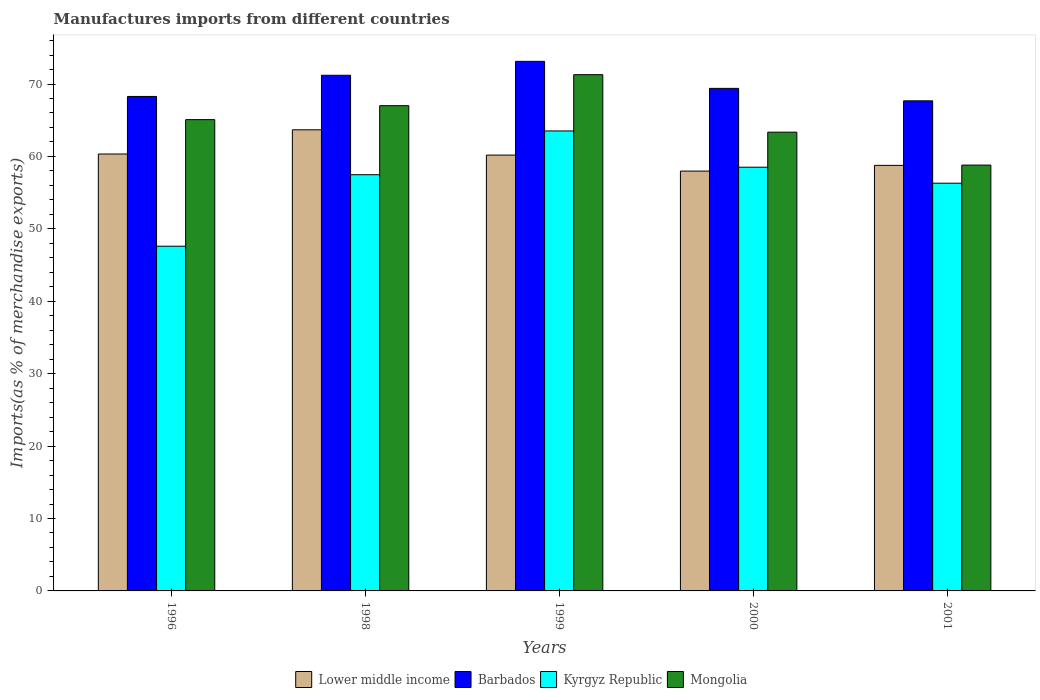How many different coloured bars are there?
Your answer should be very brief. 4. How many groups of bars are there?
Provide a succinct answer. 5. Are the number of bars on each tick of the X-axis equal?
Your answer should be compact. Yes. How many bars are there on the 2nd tick from the right?
Provide a succinct answer. 4. In how many cases, is the number of bars for a given year not equal to the number of legend labels?
Provide a short and direct response. 0. What is the percentage of imports to different countries in Barbados in 1996?
Your response must be concise. 68.28. Across all years, what is the maximum percentage of imports to different countries in Lower middle income?
Offer a terse response. 63.67. Across all years, what is the minimum percentage of imports to different countries in Lower middle income?
Provide a short and direct response. 57.98. What is the total percentage of imports to different countries in Mongolia in the graph?
Make the answer very short. 325.53. What is the difference between the percentage of imports to different countries in Lower middle income in 1998 and that in 2001?
Keep it short and to the point. 4.91. What is the difference between the percentage of imports to different countries in Lower middle income in 2001 and the percentage of imports to different countries in Mongolia in 1999?
Make the answer very short. -12.52. What is the average percentage of imports to different countries in Kyrgyz Republic per year?
Offer a terse response. 56.68. In the year 1999, what is the difference between the percentage of imports to different countries in Mongolia and percentage of imports to different countries in Kyrgyz Republic?
Your answer should be compact. 7.77. What is the ratio of the percentage of imports to different countries in Mongolia in 1998 to that in 2000?
Your answer should be very brief. 1.06. What is the difference between the highest and the second highest percentage of imports to different countries in Barbados?
Offer a terse response. 1.92. What is the difference between the highest and the lowest percentage of imports to different countries in Barbados?
Your answer should be very brief. 5.45. Is it the case that in every year, the sum of the percentage of imports to different countries in Mongolia and percentage of imports to different countries in Barbados is greater than the sum of percentage of imports to different countries in Lower middle income and percentage of imports to different countries in Kyrgyz Republic?
Give a very brief answer. Yes. What does the 3rd bar from the left in 1999 represents?
Give a very brief answer. Kyrgyz Republic. What does the 4th bar from the right in 1999 represents?
Give a very brief answer. Lower middle income. Is it the case that in every year, the sum of the percentage of imports to different countries in Barbados and percentage of imports to different countries in Lower middle income is greater than the percentage of imports to different countries in Kyrgyz Republic?
Make the answer very short. Yes. Are all the bars in the graph horizontal?
Offer a very short reply. No. What is the difference between two consecutive major ticks on the Y-axis?
Provide a succinct answer. 10. Are the values on the major ticks of Y-axis written in scientific E-notation?
Your response must be concise. No. Does the graph contain any zero values?
Your response must be concise. No. Does the graph contain grids?
Provide a succinct answer. No. Where does the legend appear in the graph?
Your answer should be compact. Bottom center. How are the legend labels stacked?
Keep it short and to the point. Horizontal. What is the title of the graph?
Your answer should be very brief. Manufactures imports from different countries. What is the label or title of the Y-axis?
Your answer should be very brief. Imports(as % of merchandise exports). What is the Imports(as % of merchandise exports) of Lower middle income in 1996?
Offer a terse response. 60.33. What is the Imports(as % of merchandise exports) of Barbados in 1996?
Offer a very short reply. 68.28. What is the Imports(as % of merchandise exports) in Kyrgyz Republic in 1996?
Provide a short and direct response. 47.6. What is the Imports(as % of merchandise exports) in Mongolia in 1996?
Provide a short and direct response. 65.08. What is the Imports(as % of merchandise exports) in Lower middle income in 1998?
Your answer should be compact. 63.67. What is the Imports(as % of merchandise exports) of Barbados in 1998?
Ensure brevity in your answer.  71.2. What is the Imports(as % of merchandise exports) of Kyrgyz Republic in 1998?
Make the answer very short. 57.47. What is the Imports(as % of merchandise exports) of Mongolia in 1998?
Ensure brevity in your answer.  67.01. What is the Imports(as % of merchandise exports) in Lower middle income in 1999?
Make the answer very short. 60.18. What is the Imports(as % of merchandise exports) of Barbados in 1999?
Your answer should be compact. 73.13. What is the Imports(as % of merchandise exports) in Kyrgyz Republic in 1999?
Offer a terse response. 63.52. What is the Imports(as % of merchandise exports) of Mongolia in 1999?
Make the answer very short. 71.29. What is the Imports(as % of merchandise exports) in Lower middle income in 2000?
Provide a short and direct response. 57.98. What is the Imports(as % of merchandise exports) in Barbados in 2000?
Your response must be concise. 69.4. What is the Imports(as % of merchandise exports) of Kyrgyz Republic in 2000?
Your answer should be very brief. 58.51. What is the Imports(as % of merchandise exports) of Mongolia in 2000?
Give a very brief answer. 63.35. What is the Imports(as % of merchandise exports) of Lower middle income in 2001?
Provide a short and direct response. 58.76. What is the Imports(as % of merchandise exports) of Barbados in 2001?
Provide a succinct answer. 67.67. What is the Imports(as % of merchandise exports) in Kyrgyz Republic in 2001?
Offer a terse response. 56.3. What is the Imports(as % of merchandise exports) in Mongolia in 2001?
Keep it short and to the point. 58.8. Across all years, what is the maximum Imports(as % of merchandise exports) of Lower middle income?
Provide a short and direct response. 63.67. Across all years, what is the maximum Imports(as % of merchandise exports) of Barbados?
Provide a succinct answer. 73.13. Across all years, what is the maximum Imports(as % of merchandise exports) of Kyrgyz Republic?
Provide a succinct answer. 63.52. Across all years, what is the maximum Imports(as % of merchandise exports) in Mongolia?
Offer a terse response. 71.29. Across all years, what is the minimum Imports(as % of merchandise exports) of Lower middle income?
Provide a succinct answer. 57.98. Across all years, what is the minimum Imports(as % of merchandise exports) of Barbados?
Your response must be concise. 67.67. Across all years, what is the minimum Imports(as % of merchandise exports) of Kyrgyz Republic?
Make the answer very short. 47.6. Across all years, what is the minimum Imports(as % of merchandise exports) in Mongolia?
Your answer should be compact. 58.8. What is the total Imports(as % of merchandise exports) of Lower middle income in the graph?
Provide a succinct answer. 300.93. What is the total Imports(as % of merchandise exports) of Barbados in the graph?
Offer a very short reply. 349.68. What is the total Imports(as % of merchandise exports) in Kyrgyz Republic in the graph?
Offer a terse response. 283.4. What is the total Imports(as % of merchandise exports) in Mongolia in the graph?
Provide a short and direct response. 325.53. What is the difference between the Imports(as % of merchandise exports) of Lower middle income in 1996 and that in 1998?
Your answer should be very brief. -3.34. What is the difference between the Imports(as % of merchandise exports) of Barbados in 1996 and that in 1998?
Ensure brevity in your answer.  -2.92. What is the difference between the Imports(as % of merchandise exports) in Kyrgyz Republic in 1996 and that in 1998?
Provide a succinct answer. -9.87. What is the difference between the Imports(as % of merchandise exports) in Mongolia in 1996 and that in 1998?
Your answer should be very brief. -1.93. What is the difference between the Imports(as % of merchandise exports) of Lower middle income in 1996 and that in 1999?
Offer a terse response. 0.15. What is the difference between the Imports(as % of merchandise exports) of Barbados in 1996 and that in 1999?
Provide a succinct answer. -4.85. What is the difference between the Imports(as % of merchandise exports) of Kyrgyz Republic in 1996 and that in 1999?
Your response must be concise. -15.92. What is the difference between the Imports(as % of merchandise exports) of Mongolia in 1996 and that in 1999?
Keep it short and to the point. -6.21. What is the difference between the Imports(as % of merchandise exports) of Lower middle income in 1996 and that in 2000?
Make the answer very short. 2.36. What is the difference between the Imports(as % of merchandise exports) of Barbados in 1996 and that in 2000?
Your response must be concise. -1.12. What is the difference between the Imports(as % of merchandise exports) of Kyrgyz Republic in 1996 and that in 2000?
Give a very brief answer. -10.91. What is the difference between the Imports(as % of merchandise exports) in Mongolia in 1996 and that in 2000?
Provide a succinct answer. 1.73. What is the difference between the Imports(as % of merchandise exports) in Lower middle income in 1996 and that in 2001?
Provide a succinct answer. 1.57. What is the difference between the Imports(as % of merchandise exports) in Barbados in 1996 and that in 2001?
Your answer should be compact. 0.61. What is the difference between the Imports(as % of merchandise exports) of Kyrgyz Republic in 1996 and that in 2001?
Keep it short and to the point. -8.7. What is the difference between the Imports(as % of merchandise exports) in Mongolia in 1996 and that in 2001?
Provide a succinct answer. 6.28. What is the difference between the Imports(as % of merchandise exports) of Lower middle income in 1998 and that in 1999?
Provide a short and direct response. 3.49. What is the difference between the Imports(as % of merchandise exports) of Barbados in 1998 and that in 1999?
Your response must be concise. -1.92. What is the difference between the Imports(as % of merchandise exports) of Kyrgyz Republic in 1998 and that in 1999?
Give a very brief answer. -6.04. What is the difference between the Imports(as % of merchandise exports) in Mongolia in 1998 and that in 1999?
Provide a short and direct response. -4.28. What is the difference between the Imports(as % of merchandise exports) of Lower middle income in 1998 and that in 2000?
Offer a terse response. 5.7. What is the difference between the Imports(as % of merchandise exports) in Barbados in 1998 and that in 2000?
Your answer should be compact. 1.81. What is the difference between the Imports(as % of merchandise exports) of Kyrgyz Republic in 1998 and that in 2000?
Your answer should be compact. -1.04. What is the difference between the Imports(as % of merchandise exports) in Mongolia in 1998 and that in 2000?
Provide a short and direct response. 3.66. What is the difference between the Imports(as % of merchandise exports) of Lower middle income in 1998 and that in 2001?
Offer a terse response. 4.91. What is the difference between the Imports(as % of merchandise exports) in Barbados in 1998 and that in 2001?
Provide a short and direct response. 3.53. What is the difference between the Imports(as % of merchandise exports) in Kyrgyz Republic in 1998 and that in 2001?
Make the answer very short. 1.17. What is the difference between the Imports(as % of merchandise exports) in Mongolia in 1998 and that in 2001?
Ensure brevity in your answer.  8.2. What is the difference between the Imports(as % of merchandise exports) in Lower middle income in 1999 and that in 2000?
Your response must be concise. 2.21. What is the difference between the Imports(as % of merchandise exports) of Barbados in 1999 and that in 2000?
Ensure brevity in your answer.  3.73. What is the difference between the Imports(as % of merchandise exports) in Kyrgyz Republic in 1999 and that in 2000?
Offer a very short reply. 5.01. What is the difference between the Imports(as % of merchandise exports) in Mongolia in 1999 and that in 2000?
Your response must be concise. 7.94. What is the difference between the Imports(as % of merchandise exports) of Lower middle income in 1999 and that in 2001?
Provide a succinct answer. 1.42. What is the difference between the Imports(as % of merchandise exports) of Barbados in 1999 and that in 2001?
Provide a succinct answer. 5.45. What is the difference between the Imports(as % of merchandise exports) in Kyrgyz Republic in 1999 and that in 2001?
Make the answer very short. 7.21. What is the difference between the Imports(as % of merchandise exports) of Mongolia in 1999 and that in 2001?
Your answer should be very brief. 12.48. What is the difference between the Imports(as % of merchandise exports) of Lower middle income in 2000 and that in 2001?
Provide a short and direct response. -0.79. What is the difference between the Imports(as % of merchandise exports) in Barbados in 2000 and that in 2001?
Give a very brief answer. 1.72. What is the difference between the Imports(as % of merchandise exports) of Kyrgyz Republic in 2000 and that in 2001?
Your response must be concise. 2.21. What is the difference between the Imports(as % of merchandise exports) in Mongolia in 2000 and that in 2001?
Provide a short and direct response. 4.55. What is the difference between the Imports(as % of merchandise exports) of Lower middle income in 1996 and the Imports(as % of merchandise exports) of Barbados in 1998?
Ensure brevity in your answer.  -10.87. What is the difference between the Imports(as % of merchandise exports) in Lower middle income in 1996 and the Imports(as % of merchandise exports) in Kyrgyz Republic in 1998?
Ensure brevity in your answer.  2.86. What is the difference between the Imports(as % of merchandise exports) in Lower middle income in 1996 and the Imports(as % of merchandise exports) in Mongolia in 1998?
Give a very brief answer. -6.67. What is the difference between the Imports(as % of merchandise exports) of Barbados in 1996 and the Imports(as % of merchandise exports) of Kyrgyz Republic in 1998?
Provide a short and direct response. 10.81. What is the difference between the Imports(as % of merchandise exports) in Barbados in 1996 and the Imports(as % of merchandise exports) in Mongolia in 1998?
Offer a terse response. 1.28. What is the difference between the Imports(as % of merchandise exports) of Kyrgyz Republic in 1996 and the Imports(as % of merchandise exports) of Mongolia in 1998?
Make the answer very short. -19.4. What is the difference between the Imports(as % of merchandise exports) in Lower middle income in 1996 and the Imports(as % of merchandise exports) in Barbados in 1999?
Your response must be concise. -12.79. What is the difference between the Imports(as % of merchandise exports) of Lower middle income in 1996 and the Imports(as % of merchandise exports) of Kyrgyz Republic in 1999?
Keep it short and to the point. -3.18. What is the difference between the Imports(as % of merchandise exports) in Lower middle income in 1996 and the Imports(as % of merchandise exports) in Mongolia in 1999?
Provide a short and direct response. -10.96. What is the difference between the Imports(as % of merchandise exports) of Barbados in 1996 and the Imports(as % of merchandise exports) of Kyrgyz Republic in 1999?
Offer a very short reply. 4.77. What is the difference between the Imports(as % of merchandise exports) in Barbados in 1996 and the Imports(as % of merchandise exports) in Mongolia in 1999?
Your response must be concise. -3.01. What is the difference between the Imports(as % of merchandise exports) of Kyrgyz Republic in 1996 and the Imports(as % of merchandise exports) of Mongolia in 1999?
Provide a succinct answer. -23.69. What is the difference between the Imports(as % of merchandise exports) in Lower middle income in 1996 and the Imports(as % of merchandise exports) in Barbados in 2000?
Give a very brief answer. -9.06. What is the difference between the Imports(as % of merchandise exports) in Lower middle income in 1996 and the Imports(as % of merchandise exports) in Kyrgyz Republic in 2000?
Your answer should be compact. 1.82. What is the difference between the Imports(as % of merchandise exports) of Lower middle income in 1996 and the Imports(as % of merchandise exports) of Mongolia in 2000?
Ensure brevity in your answer.  -3.02. What is the difference between the Imports(as % of merchandise exports) in Barbados in 1996 and the Imports(as % of merchandise exports) in Kyrgyz Republic in 2000?
Offer a terse response. 9.77. What is the difference between the Imports(as % of merchandise exports) of Barbados in 1996 and the Imports(as % of merchandise exports) of Mongolia in 2000?
Keep it short and to the point. 4.93. What is the difference between the Imports(as % of merchandise exports) in Kyrgyz Republic in 1996 and the Imports(as % of merchandise exports) in Mongolia in 2000?
Your answer should be compact. -15.75. What is the difference between the Imports(as % of merchandise exports) in Lower middle income in 1996 and the Imports(as % of merchandise exports) in Barbados in 2001?
Ensure brevity in your answer.  -7.34. What is the difference between the Imports(as % of merchandise exports) of Lower middle income in 1996 and the Imports(as % of merchandise exports) of Kyrgyz Republic in 2001?
Offer a very short reply. 4.03. What is the difference between the Imports(as % of merchandise exports) of Lower middle income in 1996 and the Imports(as % of merchandise exports) of Mongolia in 2001?
Your response must be concise. 1.53. What is the difference between the Imports(as % of merchandise exports) in Barbados in 1996 and the Imports(as % of merchandise exports) in Kyrgyz Republic in 2001?
Your answer should be compact. 11.98. What is the difference between the Imports(as % of merchandise exports) of Barbados in 1996 and the Imports(as % of merchandise exports) of Mongolia in 2001?
Your response must be concise. 9.48. What is the difference between the Imports(as % of merchandise exports) in Kyrgyz Republic in 1996 and the Imports(as % of merchandise exports) in Mongolia in 2001?
Provide a short and direct response. -11.2. What is the difference between the Imports(as % of merchandise exports) of Lower middle income in 1998 and the Imports(as % of merchandise exports) of Barbados in 1999?
Keep it short and to the point. -9.45. What is the difference between the Imports(as % of merchandise exports) of Lower middle income in 1998 and the Imports(as % of merchandise exports) of Kyrgyz Republic in 1999?
Offer a very short reply. 0.16. What is the difference between the Imports(as % of merchandise exports) in Lower middle income in 1998 and the Imports(as % of merchandise exports) in Mongolia in 1999?
Make the answer very short. -7.61. What is the difference between the Imports(as % of merchandise exports) of Barbados in 1998 and the Imports(as % of merchandise exports) of Kyrgyz Republic in 1999?
Your answer should be compact. 7.69. What is the difference between the Imports(as % of merchandise exports) of Barbados in 1998 and the Imports(as % of merchandise exports) of Mongolia in 1999?
Provide a succinct answer. -0.08. What is the difference between the Imports(as % of merchandise exports) in Kyrgyz Republic in 1998 and the Imports(as % of merchandise exports) in Mongolia in 1999?
Offer a terse response. -13.81. What is the difference between the Imports(as % of merchandise exports) in Lower middle income in 1998 and the Imports(as % of merchandise exports) in Barbados in 2000?
Offer a terse response. -5.72. What is the difference between the Imports(as % of merchandise exports) in Lower middle income in 1998 and the Imports(as % of merchandise exports) in Kyrgyz Republic in 2000?
Your answer should be very brief. 5.16. What is the difference between the Imports(as % of merchandise exports) in Lower middle income in 1998 and the Imports(as % of merchandise exports) in Mongolia in 2000?
Ensure brevity in your answer.  0.32. What is the difference between the Imports(as % of merchandise exports) in Barbados in 1998 and the Imports(as % of merchandise exports) in Kyrgyz Republic in 2000?
Your response must be concise. 12.69. What is the difference between the Imports(as % of merchandise exports) in Barbados in 1998 and the Imports(as % of merchandise exports) in Mongolia in 2000?
Your answer should be very brief. 7.85. What is the difference between the Imports(as % of merchandise exports) of Kyrgyz Republic in 1998 and the Imports(as % of merchandise exports) of Mongolia in 2000?
Provide a succinct answer. -5.88. What is the difference between the Imports(as % of merchandise exports) in Lower middle income in 1998 and the Imports(as % of merchandise exports) in Barbados in 2001?
Make the answer very short. -4. What is the difference between the Imports(as % of merchandise exports) in Lower middle income in 1998 and the Imports(as % of merchandise exports) in Kyrgyz Republic in 2001?
Offer a terse response. 7.37. What is the difference between the Imports(as % of merchandise exports) of Lower middle income in 1998 and the Imports(as % of merchandise exports) of Mongolia in 2001?
Offer a terse response. 4.87. What is the difference between the Imports(as % of merchandise exports) in Barbados in 1998 and the Imports(as % of merchandise exports) in Kyrgyz Republic in 2001?
Ensure brevity in your answer.  14.9. What is the difference between the Imports(as % of merchandise exports) of Barbados in 1998 and the Imports(as % of merchandise exports) of Mongolia in 2001?
Give a very brief answer. 12.4. What is the difference between the Imports(as % of merchandise exports) of Kyrgyz Republic in 1998 and the Imports(as % of merchandise exports) of Mongolia in 2001?
Give a very brief answer. -1.33. What is the difference between the Imports(as % of merchandise exports) in Lower middle income in 1999 and the Imports(as % of merchandise exports) in Barbados in 2000?
Keep it short and to the point. -9.21. What is the difference between the Imports(as % of merchandise exports) in Lower middle income in 1999 and the Imports(as % of merchandise exports) in Kyrgyz Republic in 2000?
Provide a short and direct response. 1.67. What is the difference between the Imports(as % of merchandise exports) of Lower middle income in 1999 and the Imports(as % of merchandise exports) of Mongolia in 2000?
Your answer should be compact. -3.17. What is the difference between the Imports(as % of merchandise exports) of Barbados in 1999 and the Imports(as % of merchandise exports) of Kyrgyz Republic in 2000?
Offer a terse response. 14.62. What is the difference between the Imports(as % of merchandise exports) in Barbados in 1999 and the Imports(as % of merchandise exports) in Mongolia in 2000?
Provide a succinct answer. 9.78. What is the difference between the Imports(as % of merchandise exports) in Kyrgyz Republic in 1999 and the Imports(as % of merchandise exports) in Mongolia in 2000?
Make the answer very short. 0.17. What is the difference between the Imports(as % of merchandise exports) of Lower middle income in 1999 and the Imports(as % of merchandise exports) of Barbados in 2001?
Ensure brevity in your answer.  -7.49. What is the difference between the Imports(as % of merchandise exports) in Lower middle income in 1999 and the Imports(as % of merchandise exports) in Kyrgyz Republic in 2001?
Ensure brevity in your answer.  3.88. What is the difference between the Imports(as % of merchandise exports) of Lower middle income in 1999 and the Imports(as % of merchandise exports) of Mongolia in 2001?
Your answer should be compact. 1.38. What is the difference between the Imports(as % of merchandise exports) of Barbados in 1999 and the Imports(as % of merchandise exports) of Kyrgyz Republic in 2001?
Offer a terse response. 16.82. What is the difference between the Imports(as % of merchandise exports) in Barbados in 1999 and the Imports(as % of merchandise exports) in Mongolia in 2001?
Offer a terse response. 14.32. What is the difference between the Imports(as % of merchandise exports) in Kyrgyz Republic in 1999 and the Imports(as % of merchandise exports) in Mongolia in 2001?
Your answer should be compact. 4.71. What is the difference between the Imports(as % of merchandise exports) of Lower middle income in 2000 and the Imports(as % of merchandise exports) of Barbados in 2001?
Offer a very short reply. -9.7. What is the difference between the Imports(as % of merchandise exports) of Lower middle income in 2000 and the Imports(as % of merchandise exports) of Kyrgyz Republic in 2001?
Offer a terse response. 1.67. What is the difference between the Imports(as % of merchandise exports) in Lower middle income in 2000 and the Imports(as % of merchandise exports) in Mongolia in 2001?
Your response must be concise. -0.83. What is the difference between the Imports(as % of merchandise exports) of Barbados in 2000 and the Imports(as % of merchandise exports) of Kyrgyz Republic in 2001?
Provide a succinct answer. 13.09. What is the difference between the Imports(as % of merchandise exports) of Barbados in 2000 and the Imports(as % of merchandise exports) of Mongolia in 2001?
Your answer should be compact. 10.59. What is the difference between the Imports(as % of merchandise exports) of Kyrgyz Republic in 2000 and the Imports(as % of merchandise exports) of Mongolia in 2001?
Give a very brief answer. -0.29. What is the average Imports(as % of merchandise exports) in Lower middle income per year?
Your response must be concise. 60.19. What is the average Imports(as % of merchandise exports) of Barbados per year?
Provide a short and direct response. 69.94. What is the average Imports(as % of merchandise exports) of Kyrgyz Republic per year?
Ensure brevity in your answer.  56.68. What is the average Imports(as % of merchandise exports) of Mongolia per year?
Offer a very short reply. 65.11. In the year 1996, what is the difference between the Imports(as % of merchandise exports) in Lower middle income and Imports(as % of merchandise exports) in Barbados?
Offer a terse response. -7.95. In the year 1996, what is the difference between the Imports(as % of merchandise exports) of Lower middle income and Imports(as % of merchandise exports) of Kyrgyz Republic?
Your answer should be compact. 12.73. In the year 1996, what is the difference between the Imports(as % of merchandise exports) of Lower middle income and Imports(as % of merchandise exports) of Mongolia?
Give a very brief answer. -4.75. In the year 1996, what is the difference between the Imports(as % of merchandise exports) in Barbados and Imports(as % of merchandise exports) in Kyrgyz Republic?
Provide a succinct answer. 20.68. In the year 1996, what is the difference between the Imports(as % of merchandise exports) of Barbados and Imports(as % of merchandise exports) of Mongolia?
Offer a very short reply. 3.2. In the year 1996, what is the difference between the Imports(as % of merchandise exports) in Kyrgyz Republic and Imports(as % of merchandise exports) in Mongolia?
Your answer should be very brief. -17.48. In the year 1998, what is the difference between the Imports(as % of merchandise exports) of Lower middle income and Imports(as % of merchandise exports) of Barbados?
Provide a short and direct response. -7.53. In the year 1998, what is the difference between the Imports(as % of merchandise exports) of Lower middle income and Imports(as % of merchandise exports) of Kyrgyz Republic?
Offer a very short reply. 6.2. In the year 1998, what is the difference between the Imports(as % of merchandise exports) in Lower middle income and Imports(as % of merchandise exports) in Mongolia?
Offer a very short reply. -3.33. In the year 1998, what is the difference between the Imports(as % of merchandise exports) of Barbados and Imports(as % of merchandise exports) of Kyrgyz Republic?
Make the answer very short. 13.73. In the year 1998, what is the difference between the Imports(as % of merchandise exports) in Barbados and Imports(as % of merchandise exports) in Mongolia?
Your answer should be very brief. 4.2. In the year 1998, what is the difference between the Imports(as % of merchandise exports) of Kyrgyz Republic and Imports(as % of merchandise exports) of Mongolia?
Provide a short and direct response. -9.53. In the year 1999, what is the difference between the Imports(as % of merchandise exports) of Lower middle income and Imports(as % of merchandise exports) of Barbados?
Your response must be concise. -12.95. In the year 1999, what is the difference between the Imports(as % of merchandise exports) in Lower middle income and Imports(as % of merchandise exports) in Kyrgyz Republic?
Provide a succinct answer. -3.33. In the year 1999, what is the difference between the Imports(as % of merchandise exports) in Lower middle income and Imports(as % of merchandise exports) in Mongolia?
Your answer should be very brief. -11.11. In the year 1999, what is the difference between the Imports(as % of merchandise exports) of Barbados and Imports(as % of merchandise exports) of Kyrgyz Republic?
Offer a very short reply. 9.61. In the year 1999, what is the difference between the Imports(as % of merchandise exports) of Barbados and Imports(as % of merchandise exports) of Mongolia?
Ensure brevity in your answer.  1.84. In the year 1999, what is the difference between the Imports(as % of merchandise exports) of Kyrgyz Republic and Imports(as % of merchandise exports) of Mongolia?
Provide a short and direct response. -7.77. In the year 2000, what is the difference between the Imports(as % of merchandise exports) in Lower middle income and Imports(as % of merchandise exports) in Barbados?
Ensure brevity in your answer.  -11.42. In the year 2000, what is the difference between the Imports(as % of merchandise exports) in Lower middle income and Imports(as % of merchandise exports) in Kyrgyz Republic?
Keep it short and to the point. -0.53. In the year 2000, what is the difference between the Imports(as % of merchandise exports) of Lower middle income and Imports(as % of merchandise exports) of Mongolia?
Your response must be concise. -5.37. In the year 2000, what is the difference between the Imports(as % of merchandise exports) in Barbados and Imports(as % of merchandise exports) in Kyrgyz Republic?
Keep it short and to the point. 10.89. In the year 2000, what is the difference between the Imports(as % of merchandise exports) of Barbados and Imports(as % of merchandise exports) of Mongolia?
Provide a succinct answer. 6.05. In the year 2000, what is the difference between the Imports(as % of merchandise exports) in Kyrgyz Republic and Imports(as % of merchandise exports) in Mongolia?
Make the answer very short. -4.84. In the year 2001, what is the difference between the Imports(as % of merchandise exports) of Lower middle income and Imports(as % of merchandise exports) of Barbados?
Provide a short and direct response. -8.91. In the year 2001, what is the difference between the Imports(as % of merchandise exports) of Lower middle income and Imports(as % of merchandise exports) of Kyrgyz Republic?
Your answer should be compact. 2.46. In the year 2001, what is the difference between the Imports(as % of merchandise exports) of Lower middle income and Imports(as % of merchandise exports) of Mongolia?
Your answer should be very brief. -0.04. In the year 2001, what is the difference between the Imports(as % of merchandise exports) of Barbados and Imports(as % of merchandise exports) of Kyrgyz Republic?
Your response must be concise. 11.37. In the year 2001, what is the difference between the Imports(as % of merchandise exports) of Barbados and Imports(as % of merchandise exports) of Mongolia?
Your answer should be very brief. 8.87. In the year 2001, what is the difference between the Imports(as % of merchandise exports) in Kyrgyz Republic and Imports(as % of merchandise exports) in Mongolia?
Offer a very short reply. -2.5. What is the ratio of the Imports(as % of merchandise exports) of Lower middle income in 1996 to that in 1998?
Keep it short and to the point. 0.95. What is the ratio of the Imports(as % of merchandise exports) in Kyrgyz Republic in 1996 to that in 1998?
Your answer should be very brief. 0.83. What is the ratio of the Imports(as % of merchandise exports) in Mongolia in 1996 to that in 1998?
Your response must be concise. 0.97. What is the ratio of the Imports(as % of merchandise exports) of Barbados in 1996 to that in 1999?
Make the answer very short. 0.93. What is the ratio of the Imports(as % of merchandise exports) in Kyrgyz Republic in 1996 to that in 1999?
Keep it short and to the point. 0.75. What is the ratio of the Imports(as % of merchandise exports) in Mongolia in 1996 to that in 1999?
Make the answer very short. 0.91. What is the ratio of the Imports(as % of merchandise exports) in Lower middle income in 1996 to that in 2000?
Offer a very short reply. 1.04. What is the ratio of the Imports(as % of merchandise exports) in Barbados in 1996 to that in 2000?
Your answer should be very brief. 0.98. What is the ratio of the Imports(as % of merchandise exports) in Kyrgyz Republic in 1996 to that in 2000?
Ensure brevity in your answer.  0.81. What is the ratio of the Imports(as % of merchandise exports) in Mongolia in 1996 to that in 2000?
Provide a succinct answer. 1.03. What is the ratio of the Imports(as % of merchandise exports) in Lower middle income in 1996 to that in 2001?
Keep it short and to the point. 1.03. What is the ratio of the Imports(as % of merchandise exports) of Kyrgyz Republic in 1996 to that in 2001?
Offer a very short reply. 0.85. What is the ratio of the Imports(as % of merchandise exports) in Mongolia in 1996 to that in 2001?
Ensure brevity in your answer.  1.11. What is the ratio of the Imports(as % of merchandise exports) of Lower middle income in 1998 to that in 1999?
Your response must be concise. 1.06. What is the ratio of the Imports(as % of merchandise exports) of Barbados in 1998 to that in 1999?
Your answer should be very brief. 0.97. What is the ratio of the Imports(as % of merchandise exports) in Kyrgyz Republic in 1998 to that in 1999?
Offer a terse response. 0.9. What is the ratio of the Imports(as % of merchandise exports) in Mongolia in 1998 to that in 1999?
Your answer should be very brief. 0.94. What is the ratio of the Imports(as % of merchandise exports) of Lower middle income in 1998 to that in 2000?
Your response must be concise. 1.1. What is the ratio of the Imports(as % of merchandise exports) in Barbados in 1998 to that in 2000?
Give a very brief answer. 1.03. What is the ratio of the Imports(as % of merchandise exports) of Kyrgyz Republic in 1998 to that in 2000?
Your answer should be very brief. 0.98. What is the ratio of the Imports(as % of merchandise exports) of Mongolia in 1998 to that in 2000?
Your answer should be very brief. 1.06. What is the ratio of the Imports(as % of merchandise exports) in Lower middle income in 1998 to that in 2001?
Your response must be concise. 1.08. What is the ratio of the Imports(as % of merchandise exports) in Barbados in 1998 to that in 2001?
Your answer should be compact. 1.05. What is the ratio of the Imports(as % of merchandise exports) in Kyrgyz Republic in 1998 to that in 2001?
Provide a short and direct response. 1.02. What is the ratio of the Imports(as % of merchandise exports) in Mongolia in 1998 to that in 2001?
Give a very brief answer. 1.14. What is the ratio of the Imports(as % of merchandise exports) in Lower middle income in 1999 to that in 2000?
Provide a short and direct response. 1.04. What is the ratio of the Imports(as % of merchandise exports) of Barbados in 1999 to that in 2000?
Provide a succinct answer. 1.05. What is the ratio of the Imports(as % of merchandise exports) in Kyrgyz Republic in 1999 to that in 2000?
Your answer should be very brief. 1.09. What is the ratio of the Imports(as % of merchandise exports) in Mongolia in 1999 to that in 2000?
Give a very brief answer. 1.13. What is the ratio of the Imports(as % of merchandise exports) in Lower middle income in 1999 to that in 2001?
Your answer should be very brief. 1.02. What is the ratio of the Imports(as % of merchandise exports) in Barbados in 1999 to that in 2001?
Provide a succinct answer. 1.08. What is the ratio of the Imports(as % of merchandise exports) in Kyrgyz Republic in 1999 to that in 2001?
Give a very brief answer. 1.13. What is the ratio of the Imports(as % of merchandise exports) of Mongolia in 1999 to that in 2001?
Your response must be concise. 1.21. What is the ratio of the Imports(as % of merchandise exports) in Lower middle income in 2000 to that in 2001?
Keep it short and to the point. 0.99. What is the ratio of the Imports(as % of merchandise exports) in Barbados in 2000 to that in 2001?
Your answer should be compact. 1.03. What is the ratio of the Imports(as % of merchandise exports) in Kyrgyz Republic in 2000 to that in 2001?
Keep it short and to the point. 1.04. What is the ratio of the Imports(as % of merchandise exports) in Mongolia in 2000 to that in 2001?
Offer a very short reply. 1.08. What is the difference between the highest and the second highest Imports(as % of merchandise exports) of Lower middle income?
Your answer should be very brief. 3.34. What is the difference between the highest and the second highest Imports(as % of merchandise exports) in Barbados?
Keep it short and to the point. 1.92. What is the difference between the highest and the second highest Imports(as % of merchandise exports) in Kyrgyz Republic?
Give a very brief answer. 5.01. What is the difference between the highest and the second highest Imports(as % of merchandise exports) of Mongolia?
Your answer should be very brief. 4.28. What is the difference between the highest and the lowest Imports(as % of merchandise exports) in Lower middle income?
Your answer should be compact. 5.7. What is the difference between the highest and the lowest Imports(as % of merchandise exports) in Barbados?
Keep it short and to the point. 5.45. What is the difference between the highest and the lowest Imports(as % of merchandise exports) in Kyrgyz Republic?
Provide a succinct answer. 15.92. What is the difference between the highest and the lowest Imports(as % of merchandise exports) of Mongolia?
Offer a terse response. 12.48. 